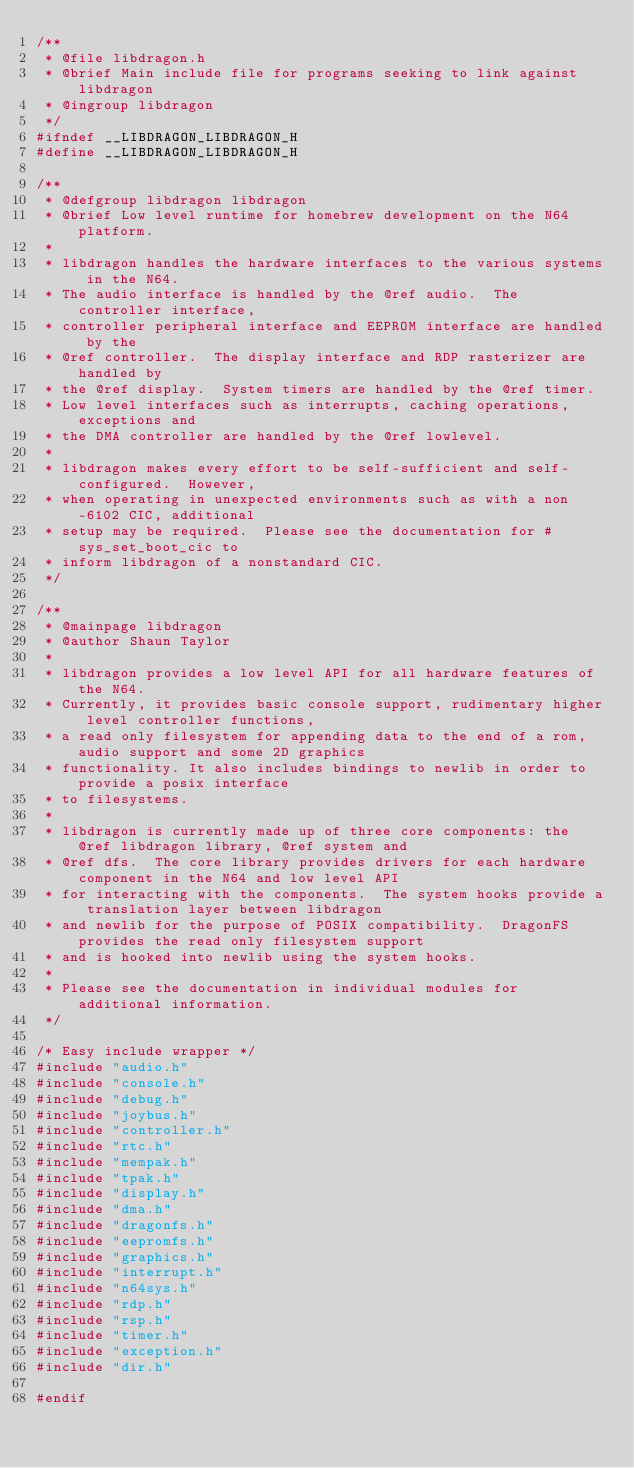<code> <loc_0><loc_0><loc_500><loc_500><_C_>/**
 * @file libdragon.h
 * @brief Main include file for programs seeking to link against libdragon
 * @ingroup libdragon
 */
#ifndef __LIBDRAGON_LIBDRAGON_H
#define __LIBDRAGON_LIBDRAGON_H

/**
 * @defgroup libdragon libdragon
 * @brief Low level runtime for homebrew development on the N64 platform.
 *
 * libdragon handles the hardware interfaces to the various systems in the N64.
 * The audio interface is handled by the @ref audio.  The controller interface,
 * controller peripheral interface and EEPROM interface are handled by the
 * @ref controller.  The display interface and RDP rasterizer are handled by
 * the @ref display.  System timers are handled by the @ref timer.
 * Low level interfaces such as interrupts, caching operations, exceptions and 
 * the DMA controller are handled by the @ref lowlevel.
 *
 * libdragon makes every effort to be self-sufficient and self-configured.  However,
 * when operating in unexpected environments such as with a non-6102 CIC, additional
 * setup may be required.  Please see the documentation for #sys_set_boot_cic to
 * inform libdragon of a nonstandard CIC.
 */

/**
 * @mainpage libdragon
 * @author Shaun Taylor
 *
 * libdragon provides a low level API for all hardware features of the N64. 
 * Currently, it provides basic console support, rudimentary higher level controller functions, 
 * a read only filesystem for appending data to the end of a rom, audio support and some 2D graphics 
 * functionality. It also includes bindings to newlib in order to provide a posix interface 
 * to filesystems.
 *
 * libdragon is currently made up of three core components: the @ref libdragon library, @ref system and
 * @ref dfs.  The core library provides drivers for each hardware component in the N64 and low level API
 * for interacting with the components.  The system hooks provide a translation layer between libdragon
 * and newlib for the purpose of POSIX compatibility.  DragonFS provides the read only filesystem support
 * and is hooked into newlib using the system hooks.
 *
 * Please see the documentation in individual modules for additional information.
 */

/* Easy include wrapper */
#include "audio.h"
#include "console.h"
#include "debug.h"
#include "joybus.h"
#include "controller.h"
#include "rtc.h"
#include "mempak.h"
#include "tpak.h"
#include "display.h"
#include "dma.h"
#include "dragonfs.h"
#include "eepromfs.h"
#include "graphics.h"
#include "interrupt.h"
#include "n64sys.h"
#include "rdp.h"
#include "rsp.h"
#include "timer.h"
#include "exception.h"
#include "dir.h"

#endif
</code> 